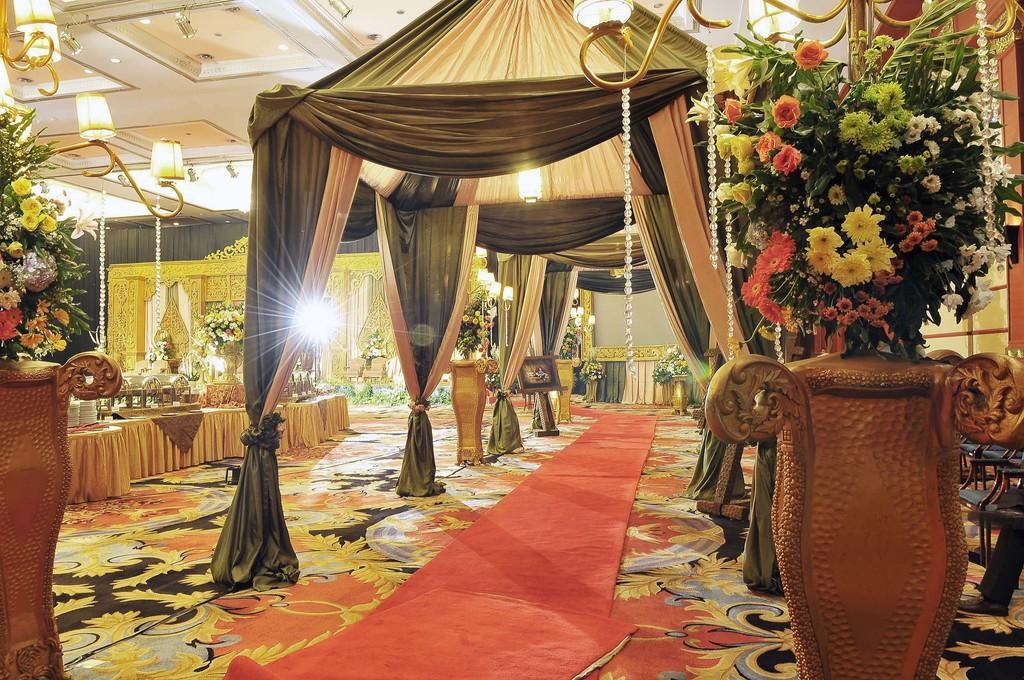Could you give a brief overview of what you see in this image? This is the inner view of a room. In this room we can see curtains, electric lights, chandeliers, house plants and crockery. 